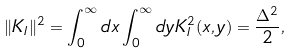<formula> <loc_0><loc_0><loc_500><loc_500>\| K _ { I } \| ^ { 2 } = \int _ { 0 } ^ { \infty } d x \int _ { 0 } ^ { \infty } d y K _ { I } ^ { 2 } ( x , y ) = { \frac { \Delta ^ { 2 } } { 2 } } ,</formula> 